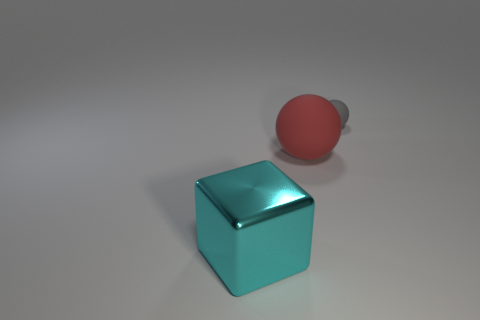Add 1 big red rubber objects. How many objects exist? 4 Subtract all red balls. How many balls are left? 1 Subtract 0 brown blocks. How many objects are left? 3 Subtract all cubes. How many objects are left? 2 Subtract 1 blocks. How many blocks are left? 0 Subtract all red blocks. Subtract all yellow cylinders. How many blocks are left? 1 Subtract all small cubes. Subtract all large cyan things. How many objects are left? 2 Add 2 big cyan metal blocks. How many big cyan metal blocks are left? 3 Add 1 tiny matte spheres. How many tiny matte spheres exist? 2 